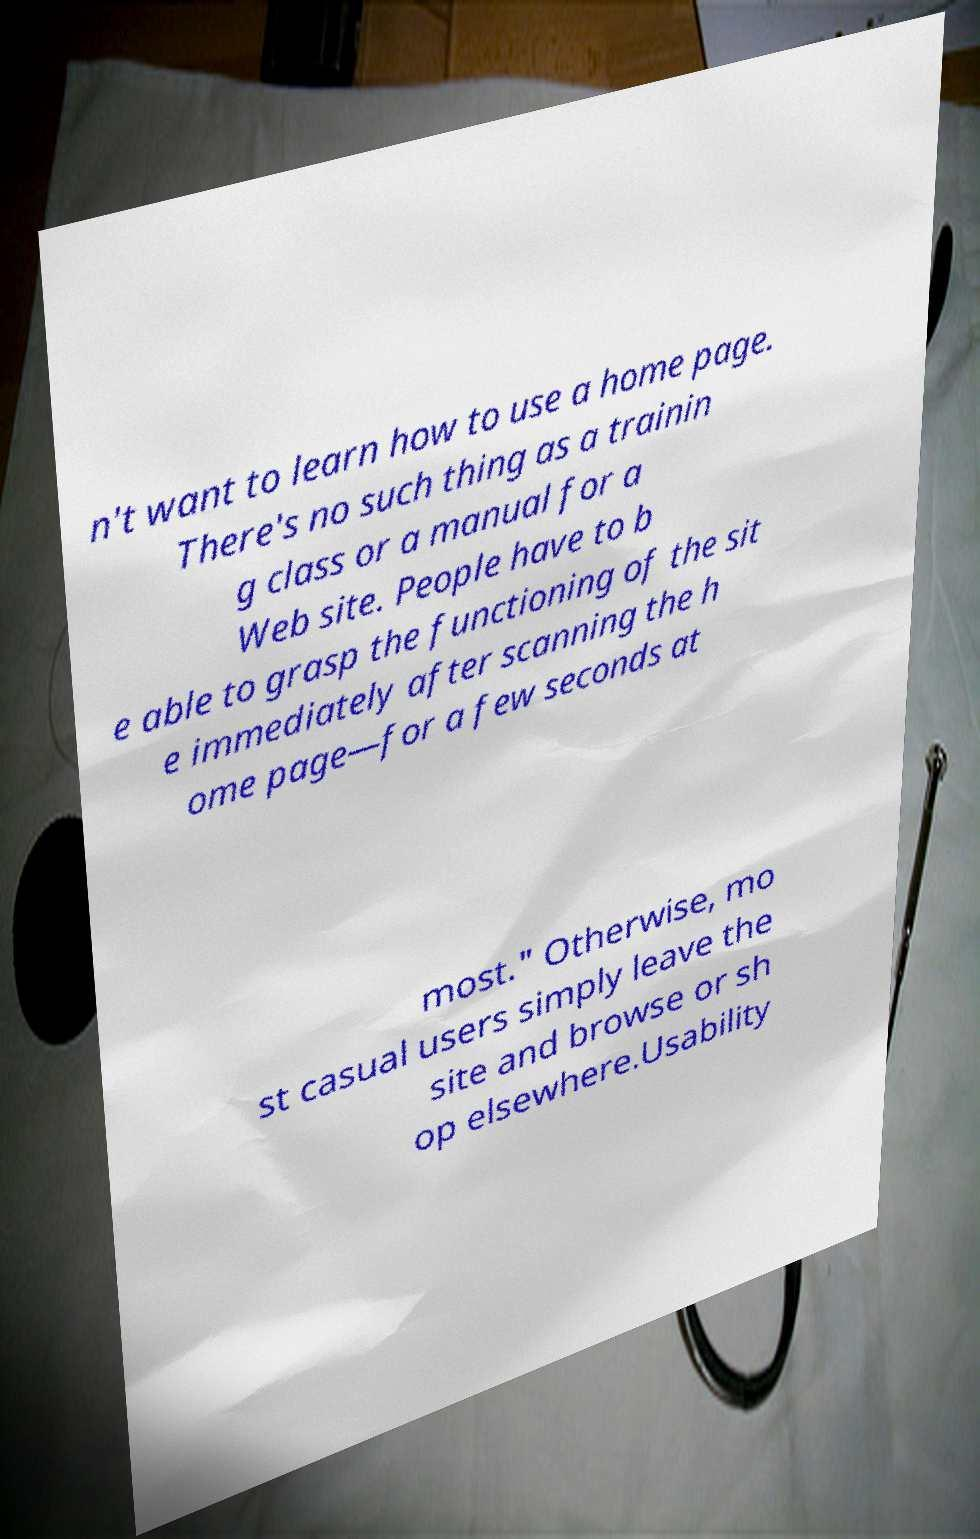Can you accurately transcribe the text from the provided image for me? n't want to learn how to use a home page. There's no such thing as a trainin g class or a manual for a Web site. People have to b e able to grasp the functioning of the sit e immediately after scanning the h ome page—for a few seconds at most." Otherwise, mo st casual users simply leave the site and browse or sh op elsewhere.Usability 